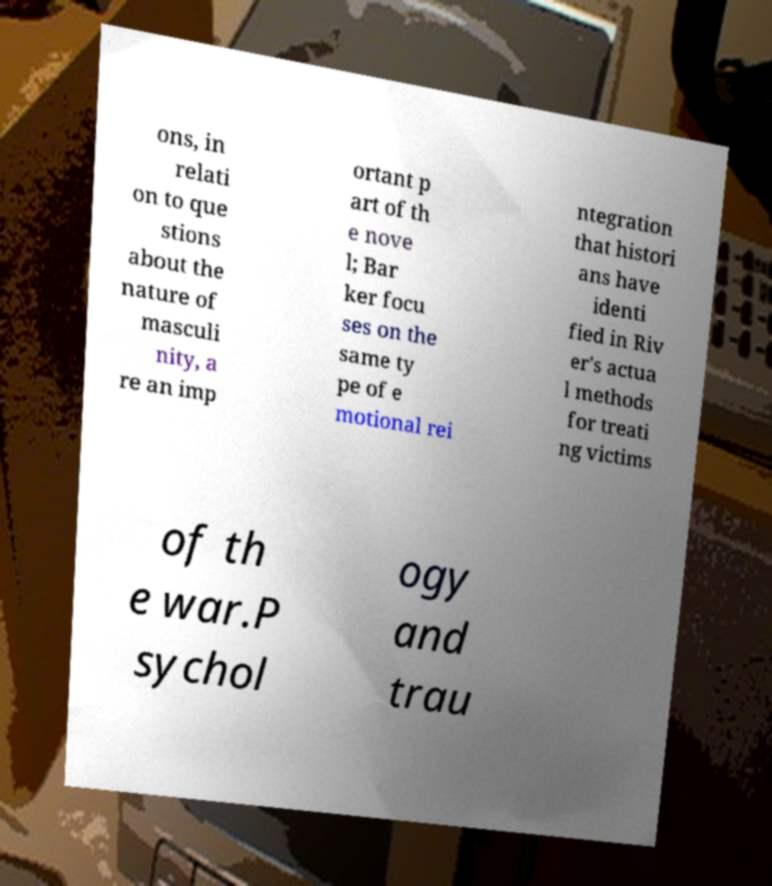What messages or text are displayed in this image? I need them in a readable, typed format. ons, in relati on to que stions about the nature of masculi nity, a re an imp ortant p art of th e nove l; Bar ker focu ses on the same ty pe of e motional rei ntegration that histori ans have identi fied in Riv er's actua l methods for treati ng victims of th e war.P sychol ogy and trau 